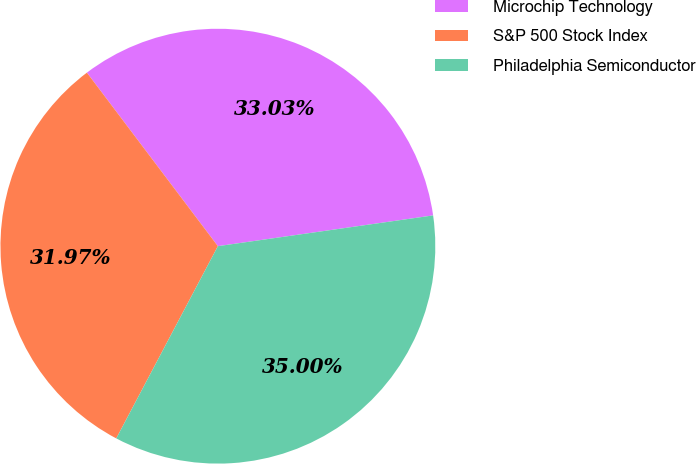<chart> <loc_0><loc_0><loc_500><loc_500><pie_chart><fcel>Microchip Technology<fcel>S&P 500 Stock Index<fcel>Philadelphia Semiconductor<nl><fcel>33.03%<fcel>31.97%<fcel>35.0%<nl></chart> 